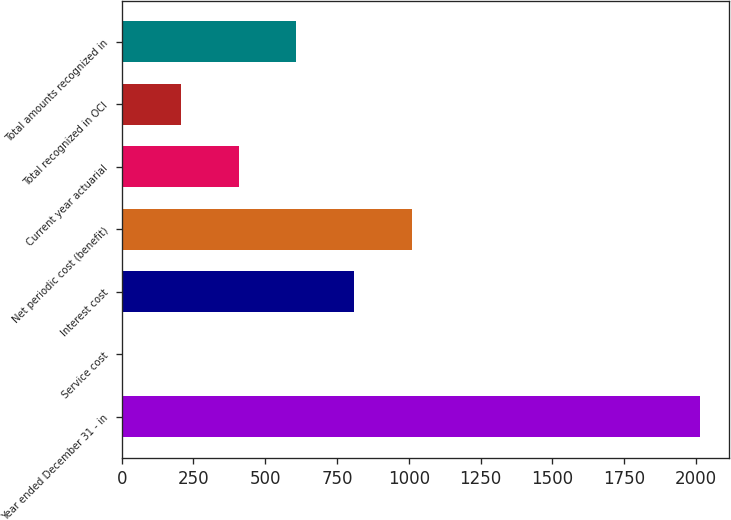Convert chart to OTSL. <chart><loc_0><loc_0><loc_500><loc_500><bar_chart><fcel>Year ended December 31 - in<fcel>Service cost<fcel>Interest cost<fcel>Net periodic cost (benefit)<fcel>Current year actuarial<fcel>Total recognized in OCI<fcel>Total amounts recognized in<nl><fcel>2013<fcel>6<fcel>808.8<fcel>1009.5<fcel>407.4<fcel>206.7<fcel>608.1<nl></chart> 